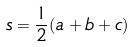<formula> <loc_0><loc_0><loc_500><loc_500>s = \frac { 1 } { 2 } ( a + b + c )</formula> 